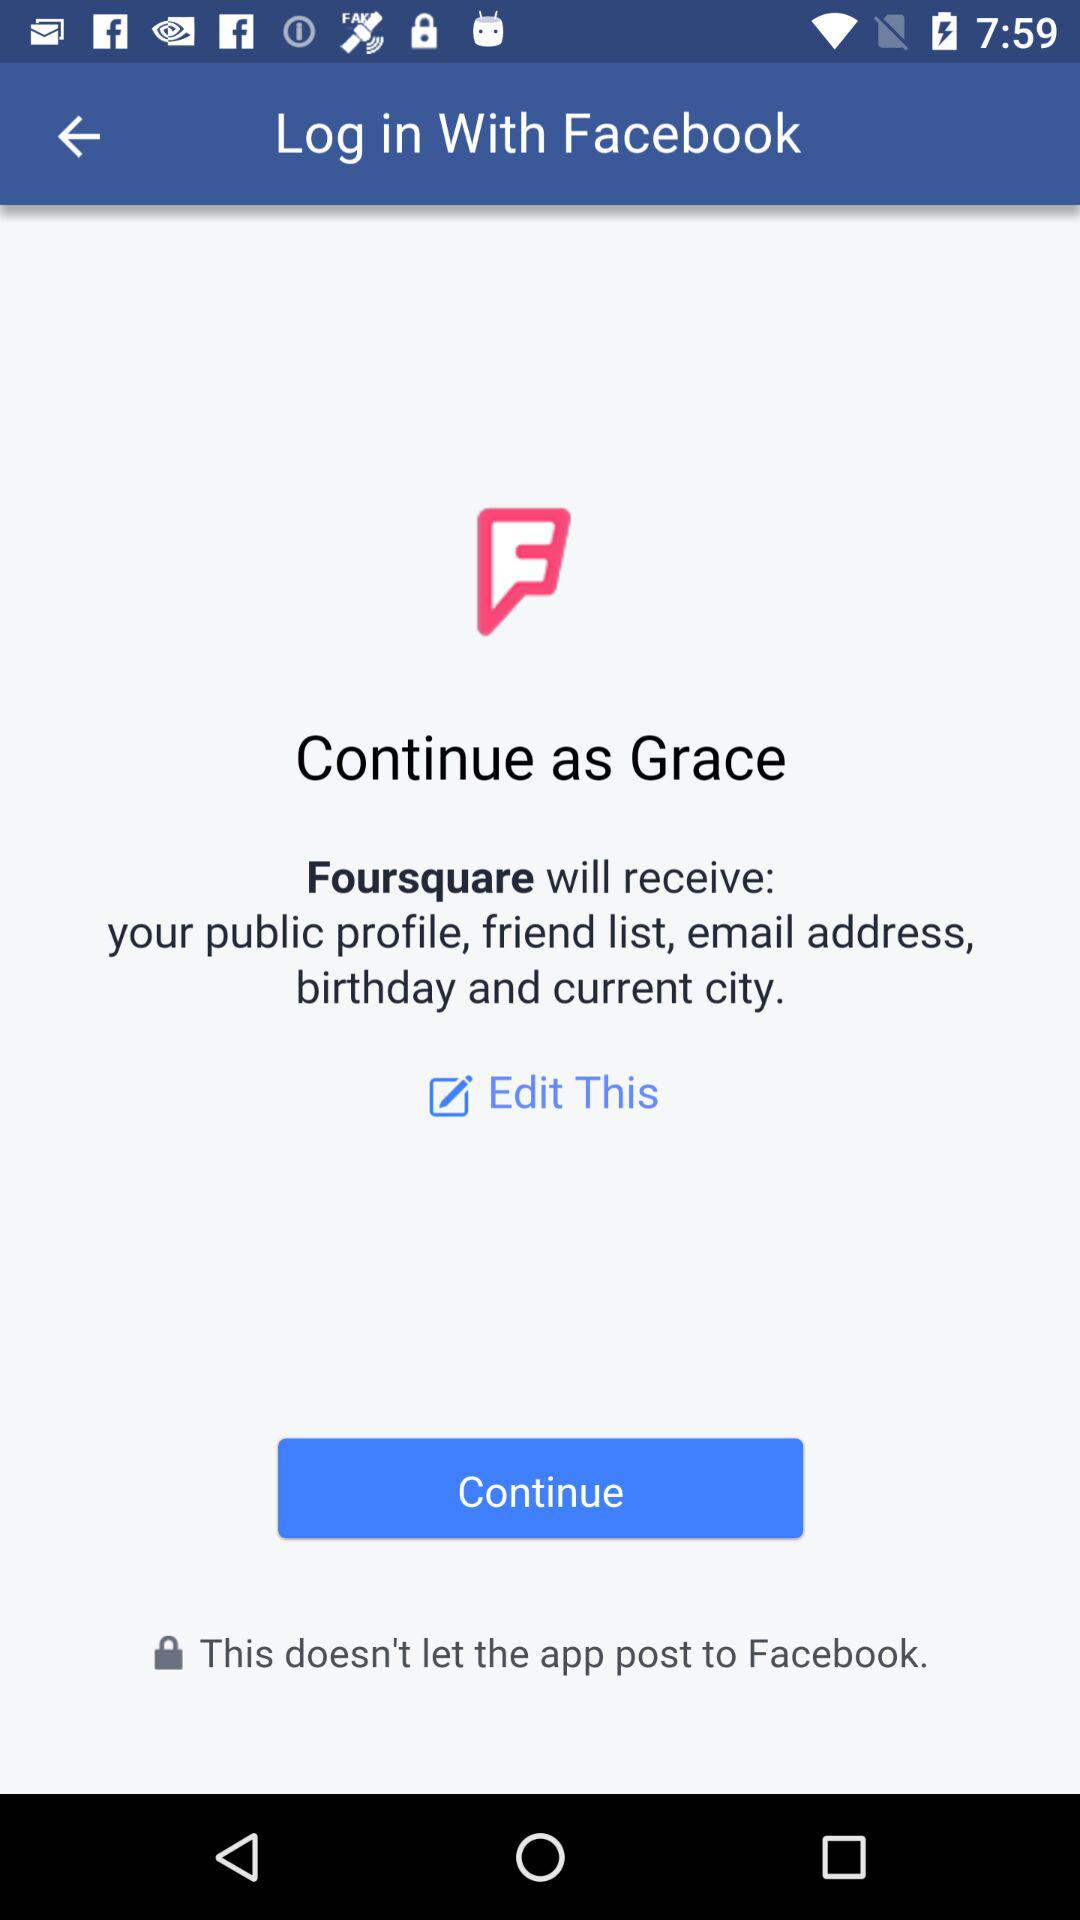Through what application can we log in? You can log in through "Facebook". 